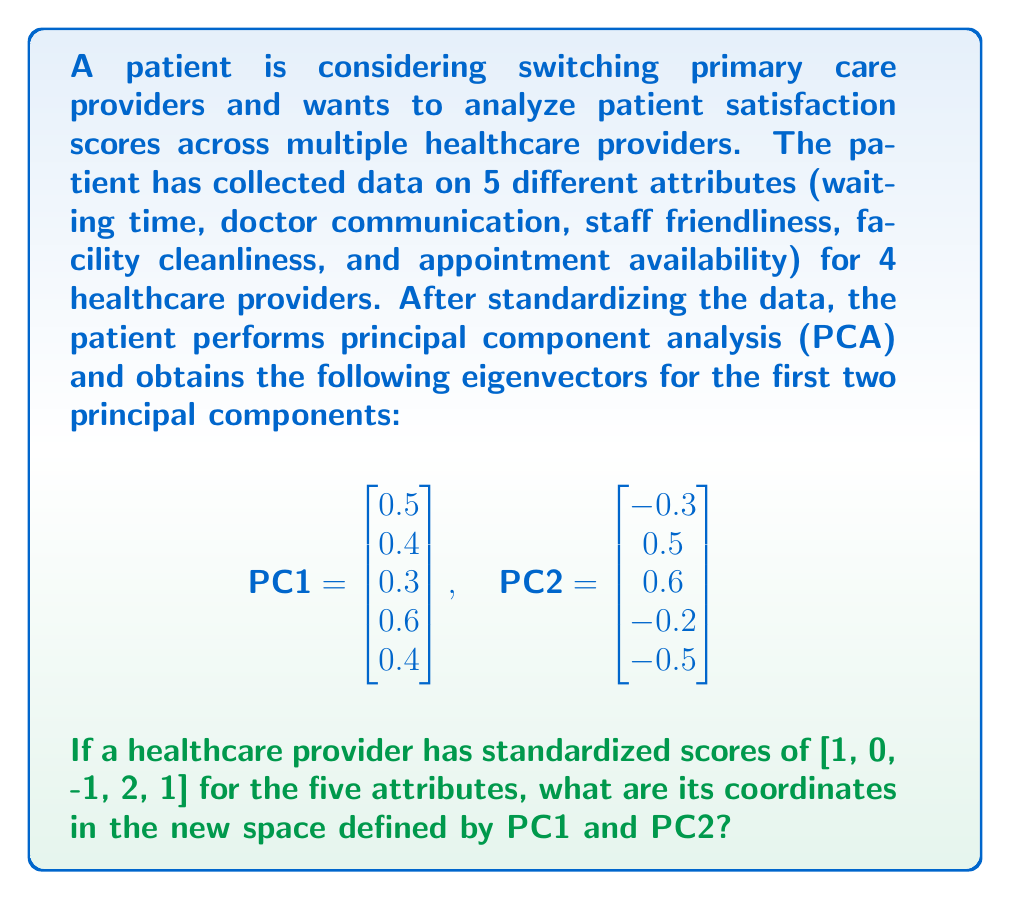Solve this math problem. To find the coordinates of the healthcare provider in the new space defined by PC1 and PC2, we need to project the standardized scores onto these principal components. This is done by calculating the dot product of the standardized scores with each principal component.

Let's denote the standardized scores as $\mathbf{x} = [1, 0, -1, 2, 1]^T$.

For PC1:
$$\begin{align}
\text{Coordinate on PC1} &= \mathbf{x}^T \cdot \text{PC1} \\
&= [1, 0, -1, 2, 1] \cdot \begin{bmatrix} 0.5 \\ 0.4 \\ 0.3 \\ 0.6 \\ 0.4 \end{bmatrix} \\
&= 1(0.5) + 0(0.4) + (-1)(0.3) + 2(0.6) + 1(0.4) \\
&= 0.5 - 0.3 + 1.2 + 0.4 \\
&= 1.8
\end{align}$$

For PC2:
$$\begin{align}
\text{Coordinate on PC2} &= \mathbf{x}^T \cdot \text{PC2} \\
&= [1, 0, -1, 2, 1] \cdot \begin{bmatrix} -0.3 \\ 0.5 \\ 0.6 \\ -0.2 \\ -0.5 \end{bmatrix} \\
&= 1(-0.3) + 0(0.5) + (-1)(0.6) + 2(-0.2) + 1(-0.5) \\
&= -0.3 - 0.6 - 0.4 - 0.5 \\
&= -1.8
\end{align}$$

Therefore, the coordinates of the healthcare provider in the new space defined by PC1 and PC2 are (1.8, -1.8).
Answer: (1.8, -1.8) 